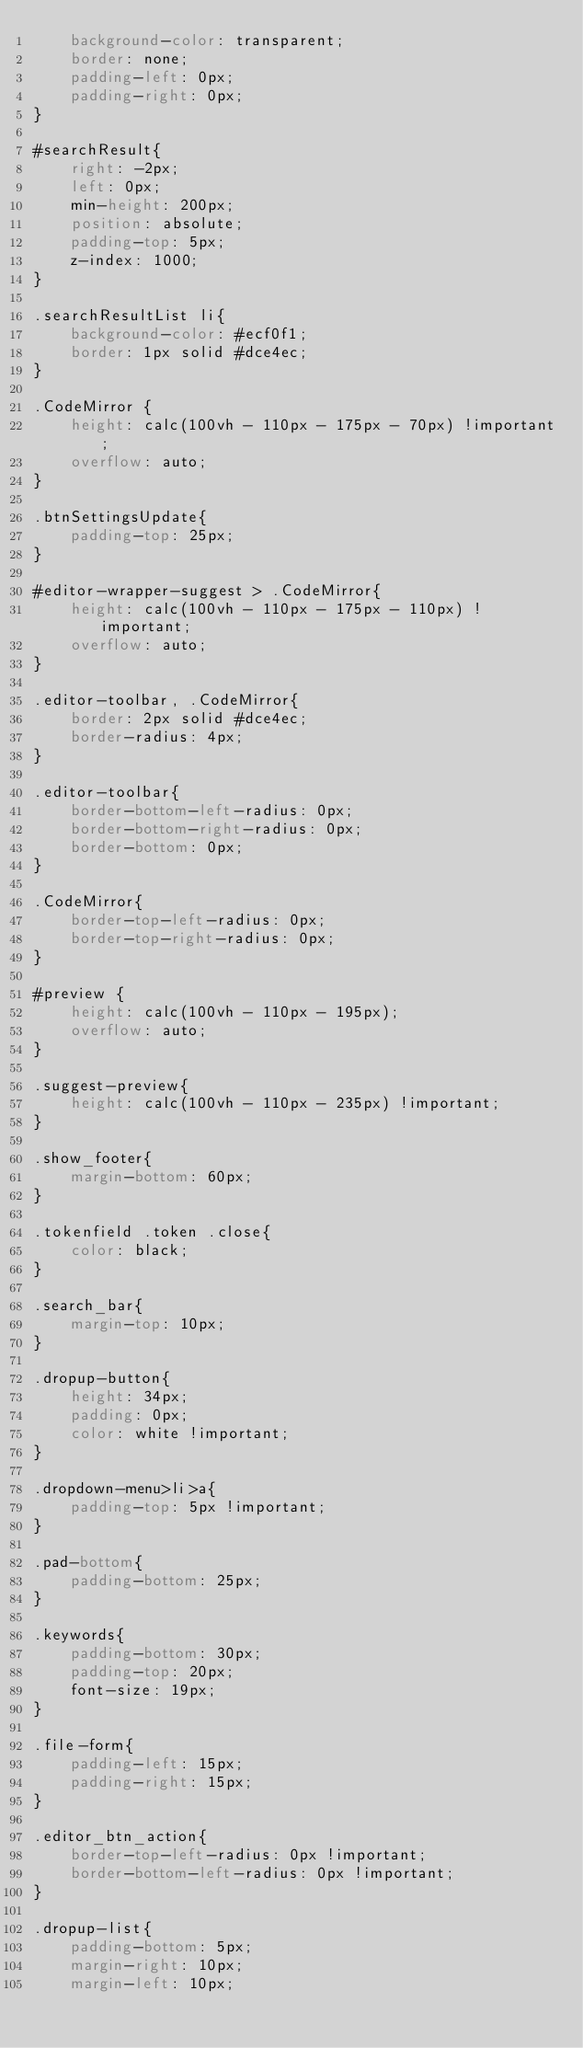Convert code to text. <code><loc_0><loc_0><loc_500><loc_500><_CSS_>    background-color: transparent;
    border: none;
    padding-left: 0px;
    padding-right: 0px;
}

#searchResult{
    right: -2px;
    left: 0px;
    min-height: 200px;
    position: absolute;
    padding-top: 5px;
    z-index: 1000;
}

.searchResultList li{
    background-color: #ecf0f1;
    border: 1px solid #dce4ec;
}

.CodeMirror {
    height: calc(100vh - 110px - 175px - 70px) !important;
    overflow: auto;
}

.btnSettingsUpdate{
    padding-top: 25px;
}

#editor-wrapper-suggest > .CodeMirror{
    height: calc(100vh - 110px - 175px - 110px) !important;
    overflow: auto;
}

.editor-toolbar, .CodeMirror{
    border: 2px solid #dce4ec;
    border-radius: 4px;
}

.editor-toolbar{
    border-bottom-left-radius: 0px;
    border-bottom-right-radius: 0px;
    border-bottom: 0px;
}

.CodeMirror{
    border-top-left-radius: 0px;
    border-top-right-radius: 0px;
}

#preview {
    height: calc(100vh - 110px - 195px);
    overflow: auto;
}

.suggest-preview{
    height: calc(100vh - 110px - 235px) !important;
}

.show_footer{
    margin-bottom: 60px;
}

.tokenfield .token .close{
    color: black;
}

.search_bar{
    margin-top: 10px;
}

.dropup-button{
    height: 34px;
    padding: 0px;
    color: white !important;
}

.dropdown-menu>li>a{
    padding-top: 5px !important;
}

.pad-bottom{
    padding-bottom: 25px;
}

.keywords{
    padding-bottom: 30px;
    padding-top: 20px;
    font-size: 19px;
}

.file-form{
    padding-left: 15px;
    padding-right: 15px;
}

.editor_btn_action{
    border-top-left-radius: 0px !important; 
    border-bottom-left-radius: 0px !important;
}

.dropup-list{
    padding-bottom: 5px;
    margin-right: 10px;
    margin-left: 10px;</code> 